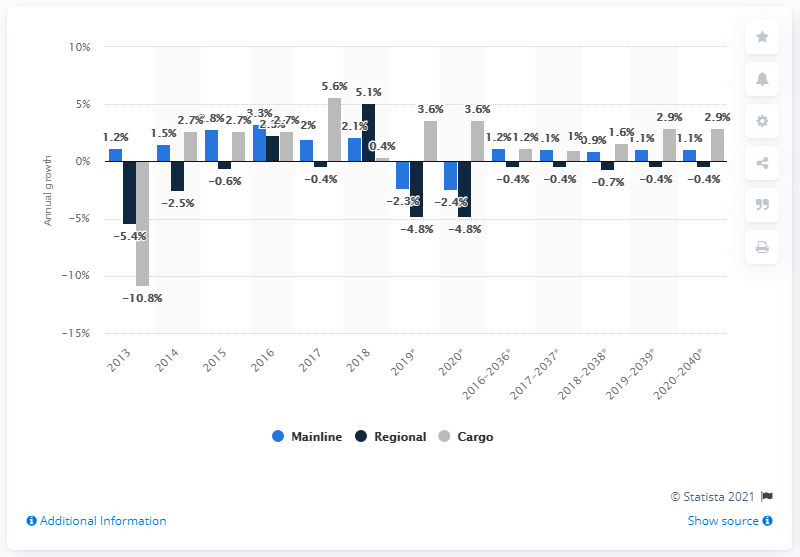List a handful of essential elements in this visual. The U.S. commercial aircraft fleet decreased by 2.3% in 2019. 